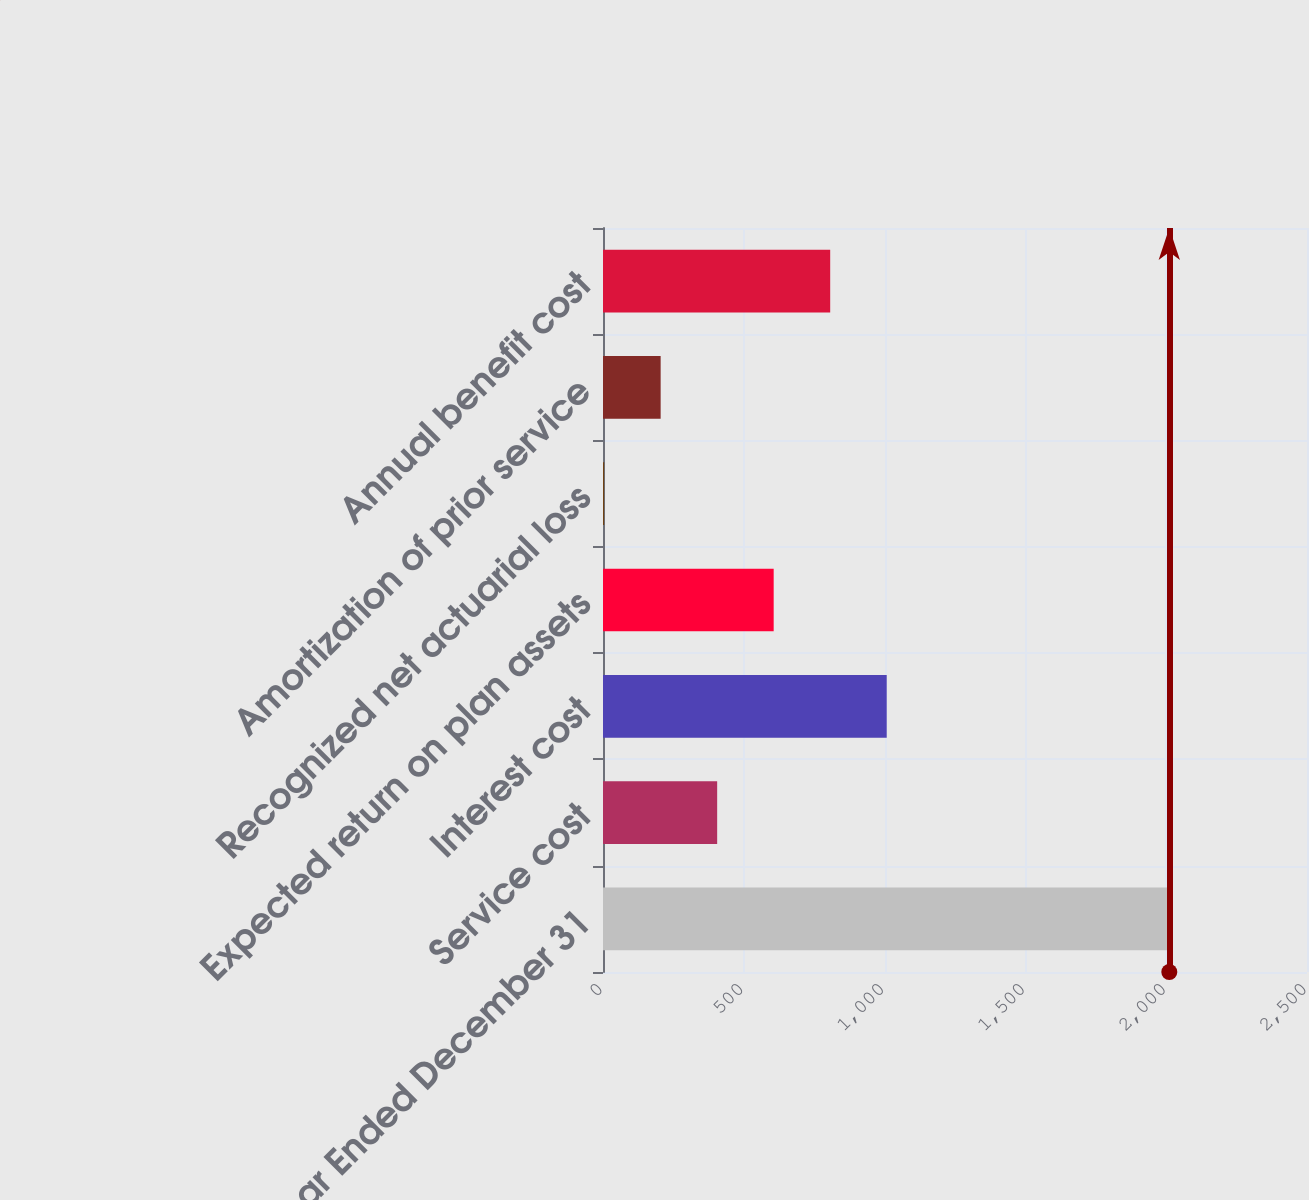Convert chart. <chart><loc_0><loc_0><loc_500><loc_500><bar_chart><fcel>Year Ended December 31<fcel>Service cost<fcel>Interest cost<fcel>Expected return on plan assets<fcel>Recognized net actuarial loss<fcel>Amortization of prior service<fcel>Annual benefit cost<nl><fcel>2011<fcel>405.4<fcel>1007.5<fcel>606.1<fcel>4<fcel>204.7<fcel>806.8<nl></chart> 